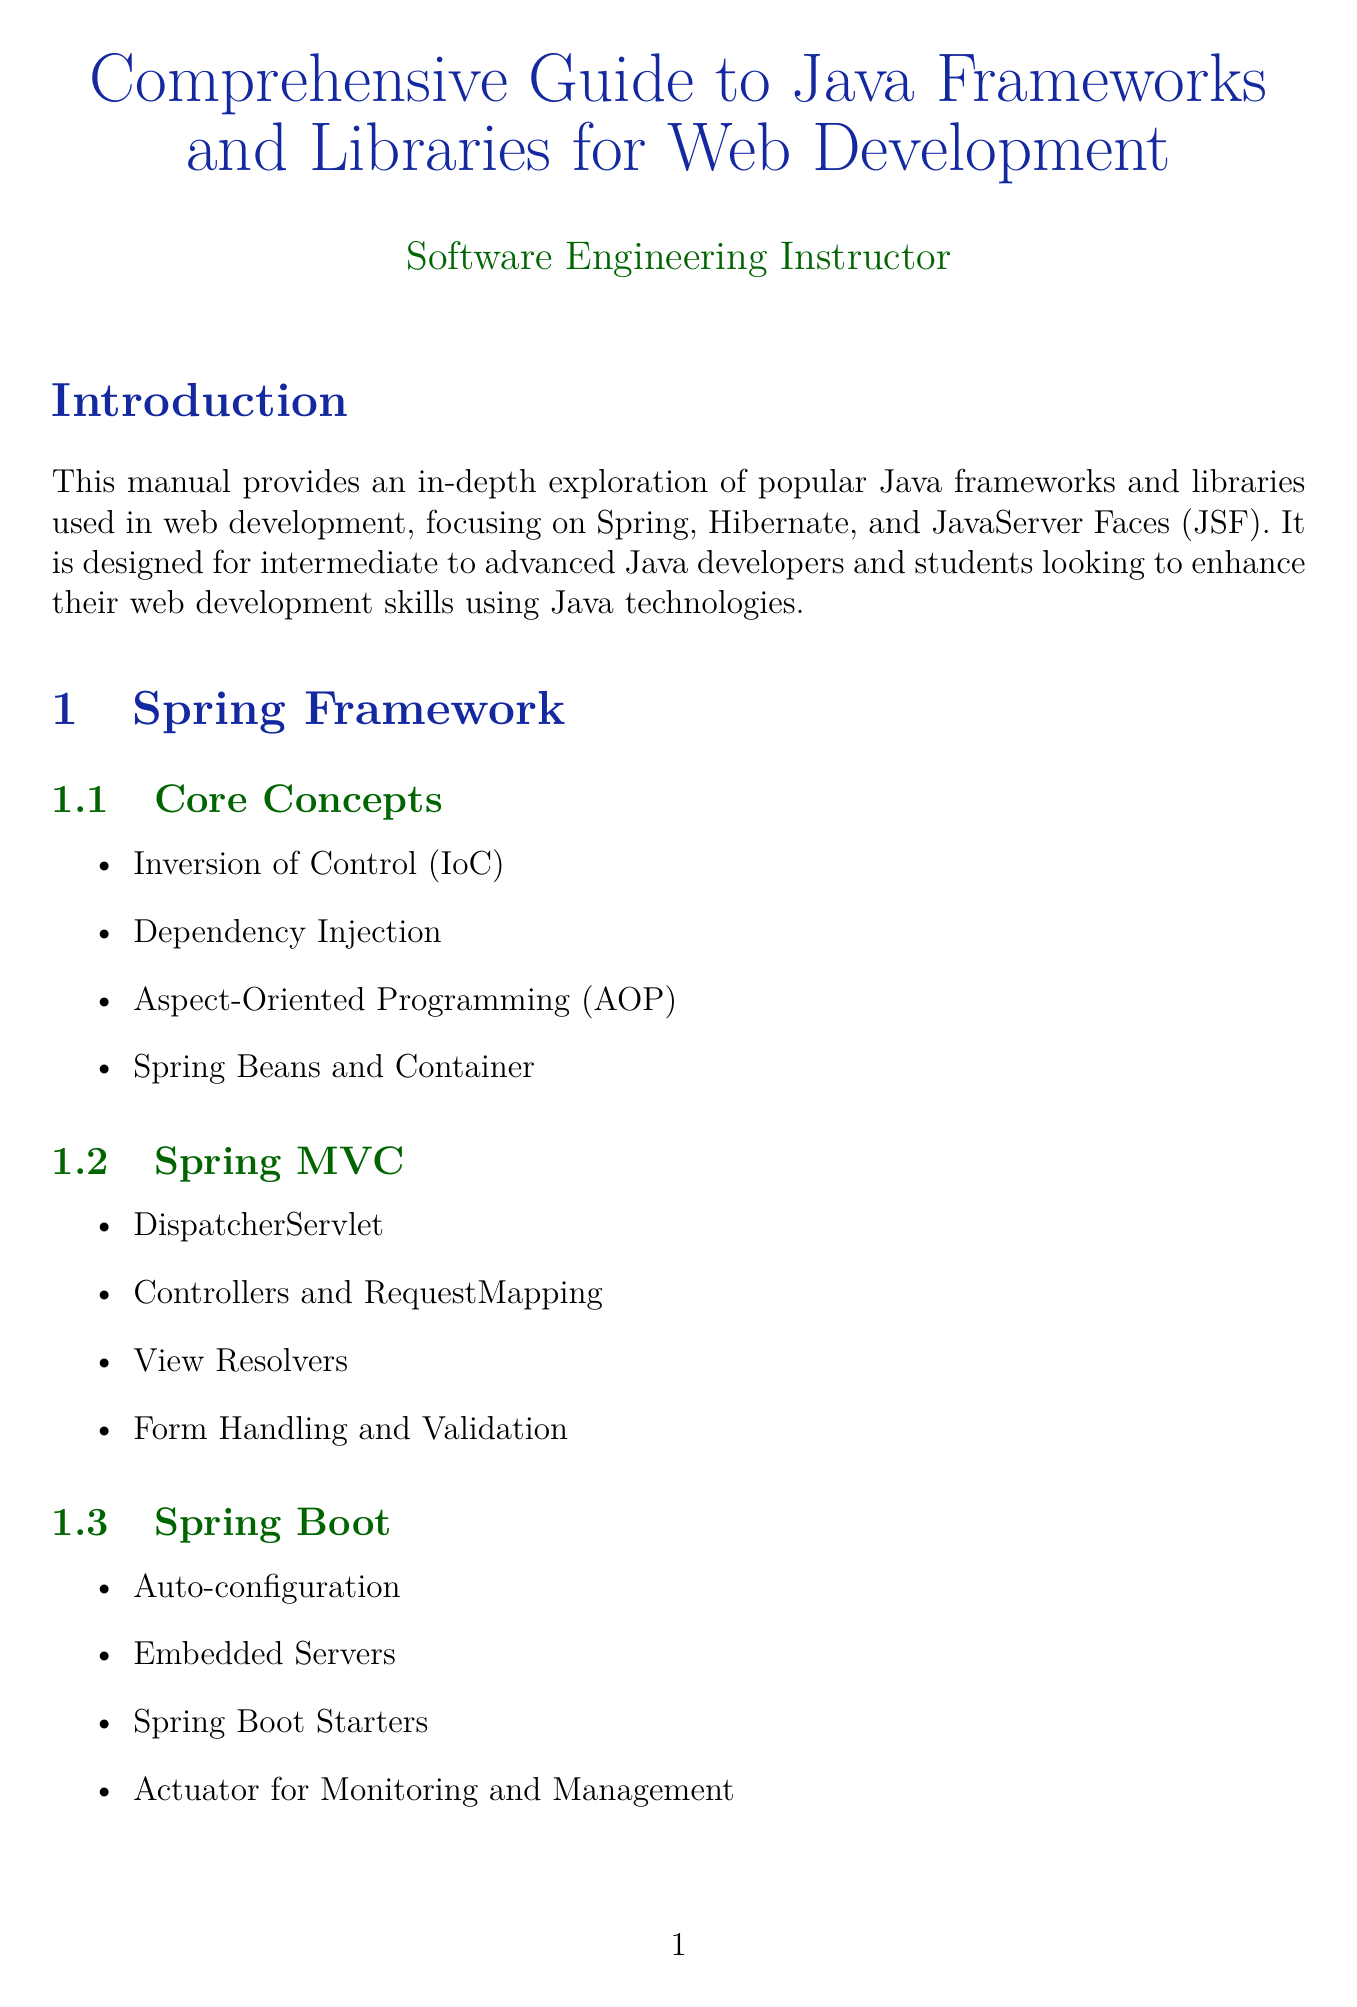What is the title of the document? The title is provided in the document's header, which is "Comprehensive Guide to Java Frameworks and Libraries for Web Development."
Answer: Comprehensive Guide to Java Frameworks and Libraries for Web Development Who is the target audience of the manual? The target audience is specified in the introduction, which mentions "Intermediate to advanced Java developers and students."
Answer: Intermediate to advanced Java developers and students What are the core concepts of the Spring Framework? The core concepts are listed under Spring Framework in the sections, which includes four specific items.
Answer: Inversion of Control, Dependency Injection, Aspect-Oriented Programming, Spring Beans and Container What does JPA stand for in the context of Spring with Hibernate? JPA is mentioned in the section discussing "Spring with Hibernate," referring to a specific configuration.
Answer: Java Persistence API Which chapter discusses performance optimization strategies? The chapter titles indicate that "Integration and Best Practices" includes a section on optimization strategies.
Answer: Integration and Best Practices What are the main components of JSF architecture? The main components are listed, which includes four essential parts.
Answer: FacesServlet, Managed Beans, Expression Language, Navigation Model What is one common pitfall mentioned in the appendix? The appendix lists several pitfalls, and the content provides examples of potential issues to be aware of.
Answer: Hibernate N+1 Select Problem How many sections are there under Hibernate ORM? The sections under Hibernate ORM are enumerated in the chapter detail, specifically four.
Answer: Four What is the purpose of the Actuator in Spring Boot? The content explicitly states that the Actuator is for a specific functionality within Spring Boot.
Answer: Monitoring and Management 